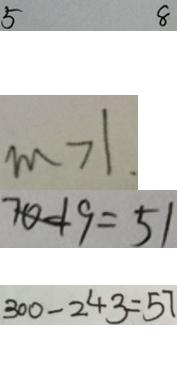<formula> <loc_0><loc_0><loc_500><loc_500>5 8 
 m > 1 . 
 7 0 - 1 9 = 5 1 
 3 0 0 - 2 4 3 = 5 7</formula> 